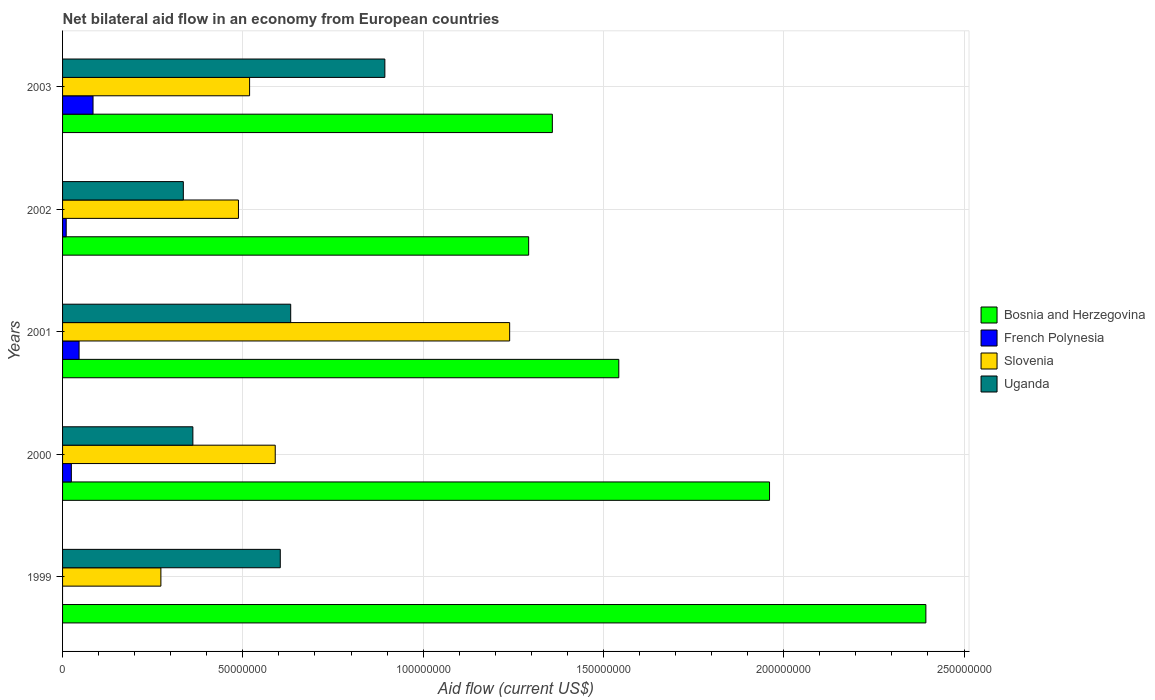Are the number of bars on each tick of the Y-axis equal?
Offer a terse response. No. How many bars are there on the 4th tick from the bottom?
Keep it short and to the point. 4. In how many cases, is the number of bars for a given year not equal to the number of legend labels?
Your answer should be compact. 1. What is the net bilateral aid flow in Slovenia in 1999?
Give a very brief answer. 2.73e+07. Across all years, what is the maximum net bilateral aid flow in Uganda?
Provide a short and direct response. 8.94e+07. Across all years, what is the minimum net bilateral aid flow in Uganda?
Offer a terse response. 3.35e+07. In which year was the net bilateral aid flow in Slovenia maximum?
Offer a terse response. 2001. What is the total net bilateral aid flow in Uganda in the graph?
Provide a short and direct response. 2.83e+08. What is the difference between the net bilateral aid flow in Slovenia in 1999 and that in 2000?
Give a very brief answer. -3.17e+07. What is the difference between the net bilateral aid flow in French Polynesia in 1999 and the net bilateral aid flow in Bosnia and Herzegovina in 2003?
Make the answer very short. -1.36e+08. What is the average net bilateral aid flow in French Polynesia per year?
Ensure brevity in your answer.  3.30e+06. In the year 2003, what is the difference between the net bilateral aid flow in Uganda and net bilateral aid flow in Slovenia?
Give a very brief answer. 3.75e+07. In how many years, is the net bilateral aid flow in Slovenia greater than 230000000 US$?
Offer a very short reply. 0. What is the ratio of the net bilateral aid flow in French Polynesia in 2001 to that in 2002?
Your answer should be very brief. 4.53. Is the net bilateral aid flow in Uganda in 2000 less than that in 2002?
Your response must be concise. No. Is the difference between the net bilateral aid flow in Uganda in 1999 and 2002 greater than the difference between the net bilateral aid flow in Slovenia in 1999 and 2002?
Make the answer very short. Yes. What is the difference between the highest and the second highest net bilateral aid flow in French Polynesia?
Make the answer very short. 3.87e+06. What is the difference between the highest and the lowest net bilateral aid flow in French Polynesia?
Your response must be concise. 8.45e+06. How many bars are there?
Ensure brevity in your answer.  19. Are all the bars in the graph horizontal?
Offer a terse response. Yes. Are the values on the major ticks of X-axis written in scientific E-notation?
Offer a very short reply. No. Does the graph contain grids?
Provide a short and direct response. Yes. Where does the legend appear in the graph?
Keep it short and to the point. Center right. How many legend labels are there?
Provide a short and direct response. 4. What is the title of the graph?
Provide a short and direct response. Net bilateral aid flow in an economy from European countries. What is the label or title of the X-axis?
Your response must be concise. Aid flow (current US$). What is the label or title of the Y-axis?
Keep it short and to the point. Years. What is the Aid flow (current US$) of Bosnia and Herzegovina in 1999?
Give a very brief answer. 2.39e+08. What is the Aid flow (current US$) in Slovenia in 1999?
Your answer should be very brief. 2.73e+07. What is the Aid flow (current US$) of Uganda in 1999?
Offer a very short reply. 6.04e+07. What is the Aid flow (current US$) in Bosnia and Herzegovina in 2000?
Make the answer very short. 1.96e+08. What is the Aid flow (current US$) in French Polynesia in 2000?
Keep it short and to the point. 2.44e+06. What is the Aid flow (current US$) of Slovenia in 2000?
Give a very brief answer. 5.90e+07. What is the Aid flow (current US$) of Uganda in 2000?
Make the answer very short. 3.61e+07. What is the Aid flow (current US$) of Bosnia and Herzegovina in 2001?
Your answer should be compact. 1.54e+08. What is the Aid flow (current US$) of French Polynesia in 2001?
Your answer should be compact. 4.58e+06. What is the Aid flow (current US$) of Slovenia in 2001?
Provide a succinct answer. 1.24e+08. What is the Aid flow (current US$) in Uganda in 2001?
Offer a terse response. 6.33e+07. What is the Aid flow (current US$) in Bosnia and Herzegovina in 2002?
Make the answer very short. 1.29e+08. What is the Aid flow (current US$) of French Polynesia in 2002?
Offer a very short reply. 1.01e+06. What is the Aid flow (current US$) in Slovenia in 2002?
Your response must be concise. 4.88e+07. What is the Aid flow (current US$) in Uganda in 2002?
Ensure brevity in your answer.  3.35e+07. What is the Aid flow (current US$) of Bosnia and Herzegovina in 2003?
Give a very brief answer. 1.36e+08. What is the Aid flow (current US$) in French Polynesia in 2003?
Keep it short and to the point. 8.45e+06. What is the Aid flow (current US$) in Slovenia in 2003?
Provide a short and direct response. 5.19e+07. What is the Aid flow (current US$) in Uganda in 2003?
Your answer should be very brief. 8.94e+07. Across all years, what is the maximum Aid flow (current US$) in Bosnia and Herzegovina?
Your answer should be very brief. 2.39e+08. Across all years, what is the maximum Aid flow (current US$) of French Polynesia?
Ensure brevity in your answer.  8.45e+06. Across all years, what is the maximum Aid flow (current US$) in Slovenia?
Offer a terse response. 1.24e+08. Across all years, what is the maximum Aid flow (current US$) in Uganda?
Provide a short and direct response. 8.94e+07. Across all years, what is the minimum Aid flow (current US$) in Bosnia and Herzegovina?
Keep it short and to the point. 1.29e+08. Across all years, what is the minimum Aid flow (current US$) of French Polynesia?
Give a very brief answer. 0. Across all years, what is the minimum Aid flow (current US$) of Slovenia?
Your answer should be compact. 2.73e+07. Across all years, what is the minimum Aid flow (current US$) of Uganda?
Your answer should be very brief. 3.35e+07. What is the total Aid flow (current US$) in Bosnia and Herzegovina in the graph?
Provide a short and direct response. 8.55e+08. What is the total Aid flow (current US$) in French Polynesia in the graph?
Provide a short and direct response. 1.65e+07. What is the total Aid flow (current US$) of Slovenia in the graph?
Offer a terse response. 3.11e+08. What is the total Aid flow (current US$) in Uganda in the graph?
Your answer should be compact. 2.83e+08. What is the difference between the Aid flow (current US$) in Bosnia and Herzegovina in 1999 and that in 2000?
Keep it short and to the point. 4.34e+07. What is the difference between the Aid flow (current US$) of Slovenia in 1999 and that in 2000?
Ensure brevity in your answer.  -3.17e+07. What is the difference between the Aid flow (current US$) of Uganda in 1999 and that in 2000?
Your response must be concise. 2.42e+07. What is the difference between the Aid flow (current US$) in Bosnia and Herzegovina in 1999 and that in 2001?
Give a very brief answer. 8.52e+07. What is the difference between the Aid flow (current US$) of Slovenia in 1999 and that in 2001?
Your answer should be very brief. -9.67e+07. What is the difference between the Aid flow (current US$) in Uganda in 1999 and that in 2001?
Ensure brevity in your answer.  -2.89e+06. What is the difference between the Aid flow (current US$) of Bosnia and Herzegovina in 1999 and that in 2002?
Your response must be concise. 1.10e+08. What is the difference between the Aid flow (current US$) in Slovenia in 1999 and that in 2002?
Your answer should be very brief. -2.15e+07. What is the difference between the Aid flow (current US$) in Uganda in 1999 and that in 2002?
Your answer should be very brief. 2.69e+07. What is the difference between the Aid flow (current US$) in Bosnia and Herzegovina in 1999 and that in 2003?
Ensure brevity in your answer.  1.04e+08. What is the difference between the Aid flow (current US$) in Slovenia in 1999 and that in 2003?
Give a very brief answer. -2.46e+07. What is the difference between the Aid flow (current US$) in Uganda in 1999 and that in 2003?
Your answer should be very brief. -2.90e+07. What is the difference between the Aid flow (current US$) of Bosnia and Herzegovina in 2000 and that in 2001?
Ensure brevity in your answer.  4.18e+07. What is the difference between the Aid flow (current US$) in French Polynesia in 2000 and that in 2001?
Provide a short and direct response. -2.14e+06. What is the difference between the Aid flow (current US$) in Slovenia in 2000 and that in 2001?
Provide a succinct answer. -6.50e+07. What is the difference between the Aid flow (current US$) of Uganda in 2000 and that in 2001?
Keep it short and to the point. -2.71e+07. What is the difference between the Aid flow (current US$) of Bosnia and Herzegovina in 2000 and that in 2002?
Offer a very short reply. 6.68e+07. What is the difference between the Aid flow (current US$) in French Polynesia in 2000 and that in 2002?
Your answer should be compact. 1.43e+06. What is the difference between the Aid flow (current US$) in Slovenia in 2000 and that in 2002?
Your answer should be compact. 1.02e+07. What is the difference between the Aid flow (current US$) of Uganda in 2000 and that in 2002?
Offer a terse response. 2.65e+06. What is the difference between the Aid flow (current US$) of Bosnia and Herzegovina in 2000 and that in 2003?
Offer a very short reply. 6.02e+07. What is the difference between the Aid flow (current US$) in French Polynesia in 2000 and that in 2003?
Give a very brief answer. -6.01e+06. What is the difference between the Aid flow (current US$) of Slovenia in 2000 and that in 2003?
Your answer should be very brief. 7.11e+06. What is the difference between the Aid flow (current US$) of Uganda in 2000 and that in 2003?
Your answer should be compact. -5.32e+07. What is the difference between the Aid flow (current US$) in Bosnia and Herzegovina in 2001 and that in 2002?
Keep it short and to the point. 2.50e+07. What is the difference between the Aid flow (current US$) of French Polynesia in 2001 and that in 2002?
Ensure brevity in your answer.  3.57e+06. What is the difference between the Aid flow (current US$) of Slovenia in 2001 and that in 2002?
Keep it short and to the point. 7.52e+07. What is the difference between the Aid flow (current US$) of Uganda in 2001 and that in 2002?
Provide a succinct answer. 2.98e+07. What is the difference between the Aid flow (current US$) in Bosnia and Herzegovina in 2001 and that in 2003?
Offer a terse response. 1.84e+07. What is the difference between the Aid flow (current US$) in French Polynesia in 2001 and that in 2003?
Offer a very short reply. -3.87e+06. What is the difference between the Aid flow (current US$) of Slovenia in 2001 and that in 2003?
Your response must be concise. 7.21e+07. What is the difference between the Aid flow (current US$) of Uganda in 2001 and that in 2003?
Provide a succinct answer. -2.61e+07. What is the difference between the Aid flow (current US$) of Bosnia and Herzegovina in 2002 and that in 2003?
Ensure brevity in your answer.  -6.57e+06. What is the difference between the Aid flow (current US$) in French Polynesia in 2002 and that in 2003?
Offer a terse response. -7.44e+06. What is the difference between the Aid flow (current US$) of Slovenia in 2002 and that in 2003?
Keep it short and to the point. -3.09e+06. What is the difference between the Aid flow (current US$) of Uganda in 2002 and that in 2003?
Your response must be concise. -5.59e+07. What is the difference between the Aid flow (current US$) in Bosnia and Herzegovina in 1999 and the Aid flow (current US$) in French Polynesia in 2000?
Give a very brief answer. 2.37e+08. What is the difference between the Aid flow (current US$) of Bosnia and Herzegovina in 1999 and the Aid flow (current US$) of Slovenia in 2000?
Offer a terse response. 1.80e+08. What is the difference between the Aid flow (current US$) in Bosnia and Herzegovina in 1999 and the Aid flow (current US$) in Uganda in 2000?
Provide a succinct answer. 2.03e+08. What is the difference between the Aid flow (current US$) of Slovenia in 1999 and the Aid flow (current US$) of Uganda in 2000?
Offer a terse response. -8.87e+06. What is the difference between the Aid flow (current US$) of Bosnia and Herzegovina in 1999 and the Aid flow (current US$) of French Polynesia in 2001?
Give a very brief answer. 2.35e+08. What is the difference between the Aid flow (current US$) of Bosnia and Herzegovina in 1999 and the Aid flow (current US$) of Slovenia in 2001?
Offer a terse response. 1.15e+08. What is the difference between the Aid flow (current US$) in Bosnia and Herzegovina in 1999 and the Aid flow (current US$) in Uganda in 2001?
Your answer should be compact. 1.76e+08. What is the difference between the Aid flow (current US$) in Slovenia in 1999 and the Aid flow (current US$) in Uganda in 2001?
Give a very brief answer. -3.60e+07. What is the difference between the Aid flow (current US$) in Bosnia and Herzegovina in 1999 and the Aid flow (current US$) in French Polynesia in 2002?
Ensure brevity in your answer.  2.38e+08. What is the difference between the Aid flow (current US$) in Bosnia and Herzegovina in 1999 and the Aid flow (current US$) in Slovenia in 2002?
Your response must be concise. 1.91e+08. What is the difference between the Aid flow (current US$) in Bosnia and Herzegovina in 1999 and the Aid flow (current US$) in Uganda in 2002?
Give a very brief answer. 2.06e+08. What is the difference between the Aid flow (current US$) of Slovenia in 1999 and the Aid flow (current US$) of Uganda in 2002?
Offer a very short reply. -6.22e+06. What is the difference between the Aid flow (current US$) of Bosnia and Herzegovina in 1999 and the Aid flow (current US$) of French Polynesia in 2003?
Ensure brevity in your answer.  2.31e+08. What is the difference between the Aid flow (current US$) in Bosnia and Herzegovina in 1999 and the Aid flow (current US$) in Slovenia in 2003?
Ensure brevity in your answer.  1.88e+08. What is the difference between the Aid flow (current US$) of Bosnia and Herzegovina in 1999 and the Aid flow (current US$) of Uganda in 2003?
Your answer should be very brief. 1.50e+08. What is the difference between the Aid flow (current US$) in Slovenia in 1999 and the Aid flow (current US$) in Uganda in 2003?
Your answer should be compact. -6.21e+07. What is the difference between the Aid flow (current US$) in Bosnia and Herzegovina in 2000 and the Aid flow (current US$) in French Polynesia in 2001?
Provide a short and direct response. 1.91e+08. What is the difference between the Aid flow (current US$) of Bosnia and Herzegovina in 2000 and the Aid flow (current US$) of Slovenia in 2001?
Give a very brief answer. 7.21e+07. What is the difference between the Aid flow (current US$) of Bosnia and Herzegovina in 2000 and the Aid flow (current US$) of Uganda in 2001?
Offer a terse response. 1.33e+08. What is the difference between the Aid flow (current US$) in French Polynesia in 2000 and the Aid flow (current US$) in Slovenia in 2001?
Provide a succinct answer. -1.22e+08. What is the difference between the Aid flow (current US$) in French Polynesia in 2000 and the Aid flow (current US$) in Uganda in 2001?
Provide a succinct answer. -6.08e+07. What is the difference between the Aid flow (current US$) of Slovenia in 2000 and the Aid flow (current US$) of Uganda in 2001?
Give a very brief answer. -4.29e+06. What is the difference between the Aid flow (current US$) of Bosnia and Herzegovina in 2000 and the Aid flow (current US$) of French Polynesia in 2002?
Provide a short and direct response. 1.95e+08. What is the difference between the Aid flow (current US$) of Bosnia and Herzegovina in 2000 and the Aid flow (current US$) of Slovenia in 2002?
Make the answer very short. 1.47e+08. What is the difference between the Aid flow (current US$) of Bosnia and Herzegovina in 2000 and the Aid flow (current US$) of Uganda in 2002?
Your answer should be very brief. 1.63e+08. What is the difference between the Aid flow (current US$) in French Polynesia in 2000 and the Aid flow (current US$) in Slovenia in 2002?
Ensure brevity in your answer.  -4.63e+07. What is the difference between the Aid flow (current US$) of French Polynesia in 2000 and the Aid flow (current US$) of Uganda in 2002?
Ensure brevity in your answer.  -3.10e+07. What is the difference between the Aid flow (current US$) of Slovenia in 2000 and the Aid flow (current US$) of Uganda in 2002?
Give a very brief answer. 2.55e+07. What is the difference between the Aid flow (current US$) of Bosnia and Herzegovina in 2000 and the Aid flow (current US$) of French Polynesia in 2003?
Provide a succinct answer. 1.88e+08. What is the difference between the Aid flow (current US$) in Bosnia and Herzegovina in 2000 and the Aid flow (current US$) in Slovenia in 2003?
Your answer should be compact. 1.44e+08. What is the difference between the Aid flow (current US$) of Bosnia and Herzegovina in 2000 and the Aid flow (current US$) of Uganda in 2003?
Give a very brief answer. 1.07e+08. What is the difference between the Aid flow (current US$) of French Polynesia in 2000 and the Aid flow (current US$) of Slovenia in 2003?
Offer a very short reply. -4.94e+07. What is the difference between the Aid flow (current US$) in French Polynesia in 2000 and the Aid flow (current US$) in Uganda in 2003?
Ensure brevity in your answer.  -8.69e+07. What is the difference between the Aid flow (current US$) in Slovenia in 2000 and the Aid flow (current US$) in Uganda in 2003?
Offer a terse response. -3.04e+07. What is the difference between the Aid flow (current US$) in Bosnia and Herzegovina in 2001 and the Aid flow (current US$) in French Polynesia in 2002?
Keep it short and to the point. 1.53e+08. What is the difference between the Aid flow (current US$) in Bosnia and Herzegovina in 2001 and the Aid flow (current US$) in Slovenia in 2002?
Make the answer very short. 1.05e+08. What is the difference between the Aid flow (current US$) of Bosnia and Herzegovina in 2001 and the Aid flow (current US$) of Uganda in 2002?
Keep it short and to the point. 1.21e+08. What is the difference between the Aid flow (current US$) of French Polynesia in 2001 and the Aid flow (current US$) of Slovenia in 2002?
Make the answer very short. -4.42e+07. What is the difference between the Aid flow (current US$) in French Polynesia in 2001 and the Aid flow (current US$) in Uganda in 2002?
Your response must be concise. -2.89e+07. What is the difference between the Aid flow (current US$) of Slovenia in 2001 and the Aid flow (current US$) of Uganda in 2002?
Offer a terse response. 9.05e+07. What is the difference between the Aid flow (current US$) of Bosnia and Herzegovina in 2001 and the Aid flow (current US$) of French Polynesia in 2003?
Offer a terse response. 1.46e+08. What is the difference between the Aid flow (current US$) of Bosnia and Herzegovina in 2001 and the Aid flow (current US$) of Slovenia in 2003?
Ensure brevity in your answer.  1.02e+08. What is the difference between the Aid flow (current US$) in Bosnia and Herzegovina in 2001 and the Aid flow (current US$) in Uganda in 2003?
Provide a succinct answer. 6.49e+07. What is the difference between the Aid flow (current US$) of French Polynesia in 2001 and the Aid flow (current US$) of Slovenia in 2003?
Your answer should be compact. -4.73e+07. What is the difference between the Aid flow (current US$) of French Polynesia in 2001 and the Aid flow (current US$) of Uganda in 2003?
Provide a short and direct response. -8.48e+07. What is the difference between the Aid flow (current US$) in Slovenia in 2001 and the Aid flow (current US$) in Uganda in 2003?
Offer a terse response. 3.46e+07. What is the difference between the Aid flow (current US$) of Bosnia and Herzegovina in 2002 and the Aid flow (current US$) of French Polynesia in 2003?
Your answer should be compact. 1.21e+08. What is the difference between the Aid flow (current US$) in Bosnia and Herzegovina in 2002 and the Aid flow (current US$) in Slovenia in 2003?
Keep it short and to the point. 7.74e+07. What is the difference between the Aid flow (current US$) in Bosnia and Herzegovina in 2002 and the Aid flow (current US$) in Uganda in 2003?
Ensure brevity in your answer.  3.99e+07. What is the difference between the Aid flow (current US$) of French Polynesia in 2002 and the Aid flow (current US$) of Slovenia in 2003?
Your answer should be compact. -5.09e+07. What is the difference between the Aid flow (current US$) of French Polynesia in 2002 and the Aid flow (current US$) of Uganda in 2003?
Keep it short and to the point. -8.84e+07. What is the difference between the Aid flow (current US$) of Slovenia in 2002 and the Aid flow (current US$) of Uganda in 2003?
Make the answer very short. -4.06e+07. What is the average Aid flow (current US$) of Bosnia and Herzegovina per year?
Make the answer very short. 1.71e+08. What is the average Aid flow (current US$) in French Polynesia per year?
Your response must be concise. 3.30e+06. What is the average Aid flow (current US$) in Slovenia per year?
Keep it short and to the point. 6.22e+07. What is the average Aid flow (current US$) of Uganda per year?
Your answer should be very brief. 5.65e+07. In the year 1999, what is the difference between the Aid flow (current US$) in Bosnia and Herzegovina and Aid flow (current US$) in Slovenia?
Your response must be concise. 2.12e+08. In the year 1999, what is the difference between the Aid flow (current US$) of Bosnia and Herzegovina and Aid flow (current US$) of Uganda?
Offer a terse response. 1.79e+08. In the year 1999, what is the difference between the Aid flow (current US$) in Slovenia and Aid flow (current US$) in Uganda?
Ensure brevity in your answer.  -3.31e+07. In the year 2000, what is the difference between the Aid flow (current US$) in Bosnia and Herzegovina and Aid flow (current US$) in French Polynesia?
Your response must be concise. 1.94e+08. In the year 2000, what is the difference between the Aid flow (current US$) of Bosnia and Herzegovina and Aid flow (current US$) of Slovenia?
Provide a succinct answer. 1.37e+08. In the year 2000, what is the difference between the Aid flow (current US$) of Bosnia and Herzegovina and Aid flow (current US$) of Uganda?
Provide a succinct answer. 1.60e+08. In the year 2000, what is the difference between the Aid flow (current US$) of French Polynesia and Aid flow (current US$) of Slovenia?
Provide a short and direct response. -5.65e+07. In the year 2000, what is the difference between the Aid flow (current US$) of French Polynesia and Aid flow (current US$) of Uganda?
Make the answer very short. -3.37e+07. In the year 2000, what is the difference between the Aid flow (current US$) in Slovenia and Aid flow (current US$) in Uganda?
Offer a very short reply. 2.28e+07. In the year 2001, what is the difference between the Aid flow (current US$) of Bosnia and Herzegovina and Aid flow (current US$) of French Polynesia?
Give a very brief answer. 1.50e+08. In the year 2001, what is the difference between the Aid flow (current US$) of Bosnia and Herzegovina and Aid flow (current US$) of Slovenia?
Make the answer very short. 3.03e+07. In the year 2001, what is the difference between the Aid flow (current US$) of Bosnia and Herzegovina and Aid flow (current US$) of Uganda?
Your response must be concise. 9.10e+07. In the year 2001, what is the difference between the Aid flow (current US$) of French Polynesia and Aid flow (current US$) of Slovenia?
Ensure brevity in your answer.  -1.19e+08. In the year 2001, what is the difference between the Aid flow (current US$) in French Polynesia and Aid flow (current US$) in Uganda?
Ensure brevity in your answer.  -5.87e+07. In the year 2001, what is the difference between the Aid flow (current US$) of Slovenia and Aid flow (current US$) of Uganda?
Provide a short and direct response. 6.07e+07. In the year 2002, what is the difference between the Aid flow (current US$) of Bosnia and Herzegovina and Aid flow (current US$) of French Polynesia?
Your answer should be compact. 1.28e+08. In the year 2002, what is the difference between the Aid flow (current US$) of Bosnia and Herzegovina and Aid flow (current US$) of Slovenia?
Offer a terse response. 8.05e+07. In the year 2002, what is the difference between the Aid flow (current US$) in Bosnia and Herzegovina and Aid flow (current US$) in Uganda?
Provide a succinct answer. 9.58e+07. In the year 2002, what is the difference between the Aid flow (current US$) of French Polynesia and Aid flow (current US$) of Slovenia?
Ensure brevity in your answer.  -4.78e+07. In the year 2002, what is the difference between the Aid flow (current US$) of French Polynesia and Aid flow (current US$) of Uganda?
Provide a succinct answer. -3.25e+07. In the year 2002, what is the difference between the Aid flow (current US$) of Slovenia and Aid flow (current US$) of Uganda?
Your response must be concise. 1.53e+07. In the year 2003, what is the difference between the Aid flow (current US$) of Bosnia and Herzegovina and Aid flow (current US$) of French Polynesia?
Offer a terse response. 1.27e+08. In the year 2003, what is the difference between the Aid flow (current US$) in Bosnia and Herzegovina and Aid flow (current US$) in Slovenia?
Make the answer very short. 8.40e+07. In the year 2003, what is the difference between the Aid flow (current US$) in Bosnia and Herzegovina and Aid flow (current US$) in Uganda?
Offer a very short reply. 4.64e+07. In the year 2003, what is the difference between the Aid flow (current US$) in French Polynesia and Aid flow (current US$) in Slovenia?
Ensure brevity in your answer.  -4.34e+07. In the year 2003, what is the difference between the Aid flow (current US$) of French Polynesia and Aid flow (current US$) of Uganda?
Your answer should be very brief. -8.09e+07. In the year 2003, what is the difference between the Aid flow (current US$) of Slovenia and Aid flow (current US$) of Uganda?
Your response must be concise. -3.75e+07. What is the ratio of the Aid flow (current US$) of Bosnia and Herzegovina in 1999 to that in 2000?
Ensure brevity in your answer.  1.22. What is the ratio of the Aid flow (current US$) in Slovenia in 1999 to that in 2000?
Ensure brevity in your answer.  0.46. What is the ratio of the Aid flow (current US$) of Uganda in 1999 to that in 2000?
Your answer should be compact. 1.67. What is the ratio of the Aid flow (current US$) of Bosnia and Herzegovina in 1999 to that in 2001?
Make the answer very short. 1.55. What is the ratio of the Aid flow (current US$) of Slovenia in 1999 to that in 2001?
Make the answer very short. 0.22. What is the ratio of the Aid flow (current US$) of Uganda in 1999 to that in 2001?
Make the answer very short. 0.95. What is the ratio of the Aid flow (current US$) in Bosnia and Herzegovina in 1999 to that in 2002?
Ensure brevity in your answer.  1.85. What is the ratio of the Aid flow (current US$) of Slovenia in 1999 to that in 2002?
Your response must be concise. 0.56. What is the ratio of the Aid flow (current US$) in Uganda in 1999 to that in 2002?
Your response must be concise. 1.8. What is the ratio of the Aid flow (current US$) of Bosnia and Herzegovina in 1999 to that in 2003?
Make the answer very short. 1.76. What is the ratio of the Aid flow (current US$) in Slovenia in 1999 to that in 2003?
Your answer should be very brief. 0.53. What is the ratio of the Aid flow (current US$) of Uganda in 1999 to that in 2003?
Offer a terse response. 0.68. What is the ratio of the Aid flow (current US$) of Bosnia and Herzegovina in 2000 to that in 2001?
Your answer should be very brief. 1.27. What is the ratio of the Aid flow (current US$) of French Polynesia in 2000 to that in 2001?
Provide a short and direct response. 0.53. What is the ratio of the Aid flow (current US$) of Slovenia in 2000 to that in 2001?
Your response must be concise. 0.48. What is the ratio of the Aid flow (current US$) of Uganda in 2000 to that in 2001?
Your response must be concise. 0.57. What is the ratio of the Aid flow (current US$) in Bosnia and Herzegovina in 2000 to that in 2002?
Provide a succinct answer. 1.52. What is the ratio of the Aid flow (current US$) in French Polynesia in 2000 to that in 2002?
Make the answer very short. 2.42. What is the ratio of the Aid flow (current US$) in Slovenia in 2000 to that in 2002?
Your answer should be very brief. 1.21. What is the ratio of the Aid flow (current US$) in Uganda in 2000 to that in 2002?
Your answer should be compact. 1.08. What is the ratio of the Aid flow (current US$) in Bosnia and Herzegovina in 2000 to that in 2003?
Provide a succinct answer. 1.44. What is the ratio of the Aid flow (current US$) in French Polynesia in 2000 to that in 2003?
Keep it short and to the point. 0.29. What is the ratio of the Aid flow (current US$) in Slovenia in 2000 to that in 2003?
Give a very brief answer. 1.14. What is the ratio of the Aid flow (current US$) in Uganda in 2000 to that in 2003?
Give a very brief answer. 0.4. What is the ratio of the Aid flow (current US$) in Bosnia and Herzegovina in 2001 to that in 2002?
Give a very brief answer. 1.19. What is the ratio of the Aid flow (current US$) in French Polynesia in 2001 to that in 2002?
Make the answer very short. 4.53. What is the ratio of the Aid flow (current US$) of Slovenia in 2001 to that in 2002?
Make the answer very short. 2.54. What is the ratio of the Aid flow (current US$) in Uganda in 2001 to that in 2002?
Ensure brevity in your answer.  1.89. What is the ratio of the Aid flow (current US$) in Bosnia and Herzegovina in 2001 to that in 2003?
Provide a short and direct response. 1.14. What is the ratio of the Aid flow (current US$) in French Polynesia in 2001 to that in 2003?
Provide a short and direct response. 0.54. What is the ratio of the Aid flow (current US$) of Slovenia in 2001 to that in 2003?
Offer a terse response. 2.39. What is the ratio of the Aid flow (current US$) of Uganda in 2001 to that in 2003?
Give a very brief answer. 0.71. What is the ratio of the Aid flow (current US$) in Bosnia and Herzegovina in 2002 to that in 2003?
Provide a succinct answer. 0.95. What is the ratio of the Aid flow (current US$) of French Polynesia in 2002 to that in 2003?
Provide a short and direct response. 0.12. What is the ratio of the Aid flow (current US$) in Slovenia in 2002 to that in 2003?
Provide a succinct answer. 0.94. What is the ratio of the Aid flow (current US$) of Uganda in 2002 to that in 2003?
Ensure brevity in your answer.  0.37. What is the difference between the highest and the second highest Aid flow (current US$) of Bosnia and Herzegovina?
Provide a succinct answer. 4.34e+07. What is the difference between the highest and the second highest Aid flow (current US$) of French Polynesia?
Offer a very short reply. 3.87e+06. What is the difference between the highest and the second highest Aid flow (current US$) in Slovenia?
Keep it short and to the point. 6.50e+07. What is the difference between the highest and the second highest Aid flow (current US$) in Uganda?
Keep it short and to the point. 2.61e+07. What is the difference between the highest and the lowest Aid flow (current US$) in Bosnia and Herzegovina?
Offer a very short reply. 1.10e+08. What is the difference between the highest and the lowest Aid flow (current US$) of French Polynesia?
Provide a succinct answer. 8.45e+06. What is the difference between the highest and the lowest Aid flow (current US$) of Slovenia?
Offer a very short reply. 9.67e+07. What is the difference between the highest and the lowest Aid flow (current US$) of Uganda?
Your response must be concise. 5.59e+07. 